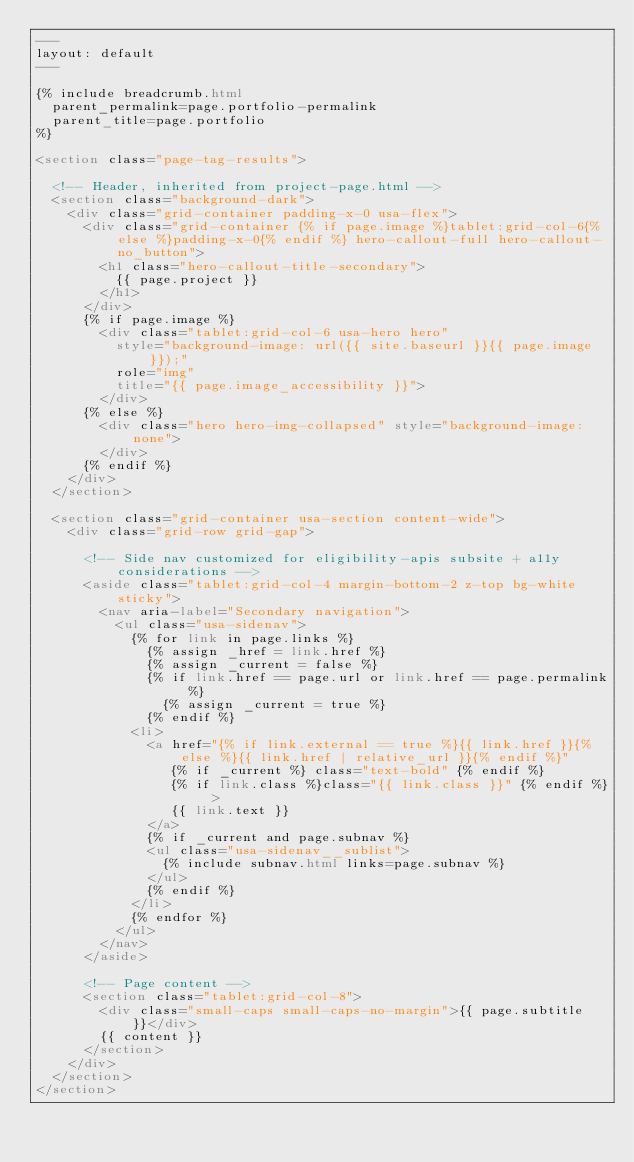<code> <loc_0><loc_0><loc_500><loc_500><_HTML_>---
layout: default
---

{% include breadcrumb.html
  parent_permalink=page.portfolio-permalink
  parent_title=page.portfolio
%}

<section class="page-tag-results">

  <!-- Header, inherited from project-page.html -->
  <section class="background-dark">
    <div class="grid-container padding-x-0 usa-flex">
      <div class="grid-container {% if page.image %}tablet:grid-col-6{% else %}padding-x-0{% endif %} hero-callout-full hero-callout-no_button">
        <h1 class="hero-callout-title-secondary">
          {{ page.project }}
        </h1>
      </div>
      {% if page.image %}
        <div class="tablet:grid-col-6 usa-hero hero"
          style="background-image: url({{ site.baseurl }}{{ page.image }});"
          role="img"
          title="{{ page.image_accessibility }}">
        </div>
      {% else %}
        <div class="hero hero-img-collapsed" style="background-image: none">
        </div>
      {% endif %}
    </div>
  </section>

  <section class="grid-container usa-section content-wide">
    <div class="grid-row grid-gap">

      <!-- Side nav customized for eligibility-apis subsite + a11y considerations -->
      <aside class="tablet:grid-col-4 margin-bottom-2 z-top bg-white sticky">
        <nav aria-label="Secondary navigation">
          <ul class="usa-sidenav">
            {% for link in page.links %}
              {% assign _href = link.href %}
              {% assign _current = false %}
              {% if link.href == page.url or link.href == page.permalink %}
                {% assign _current = true %}
              {% endif %}
            <li>
              <a href="{% if link.external == true %}{{ link.href }}{% else %}{{ link.href | relative_url }}{% endif %}"
                 {% if _current %} class="text-bold" {% endif %}
                 {% if link.class %}class="{{ link.class }}" {% endif %} >
                 {{ link.text }}
              </a>
              {% if _current and page.subnav %}
              <ul class="usa-sidenav__sublist">
                {% include subnav.html links=page.subnav %}
              </ul>
              {% endif %}
            </li>
            {% endfor %}
          </ul>
        </nav>
      </aside>

      <!-- Page content -->
      <section class="tablet:grid-col-8">
        <div class="small-caps small-caps-no-margin">{{ page.subtitle }}</div>
        {{ content }}
      </section>
    </div>
  </section>
</section>
</code> 